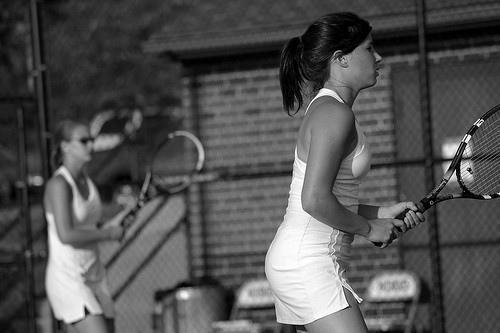How many chairs are there?
Give a very brief answer. 2. How many people can be seen?
Give a very brief answer. 2. How many tennis rackets can be seen?
Give a very brief answer. 2. How many dogs are on the bed?
Give a very brief answer. 0. 